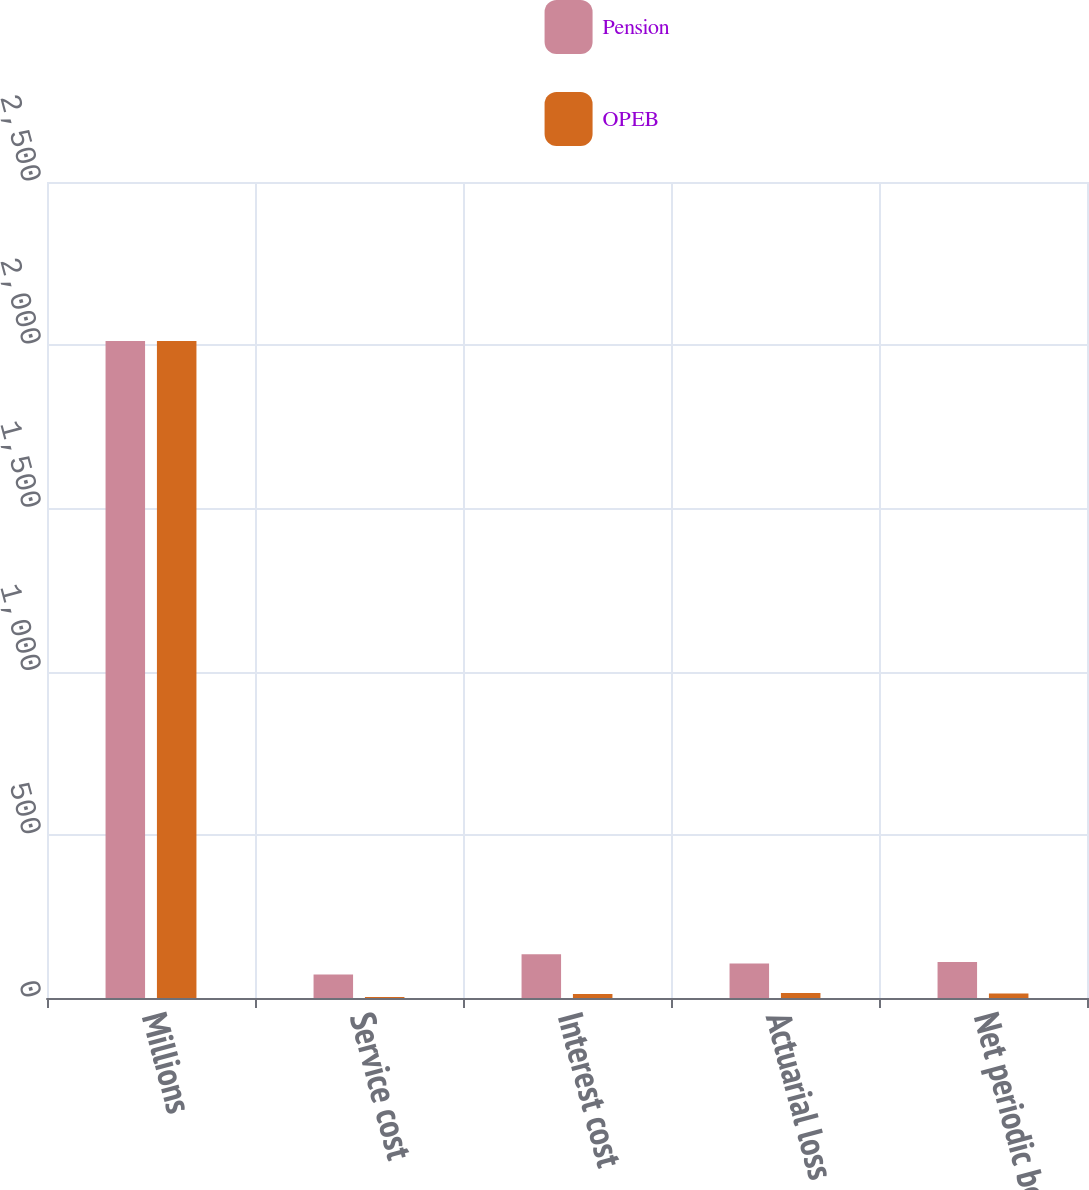Convert chart. <chart><loc_0><loc_0><loc_500><loc_500><stacked_bar_chart><ecel><fcel>Millions<fcel>Service cost<fcel>Interest cost<fcel>Actuarial loss<fcel>Net periodic benefit<nl><fcel>Pension<fcel>2013<fcel>72<fcel>134<fcel>106<fcel>110<nl><fcel>OPEB<fcel>2013<fcel>3<fcel>12<fcel>15<fcel>14<nl></chart> 